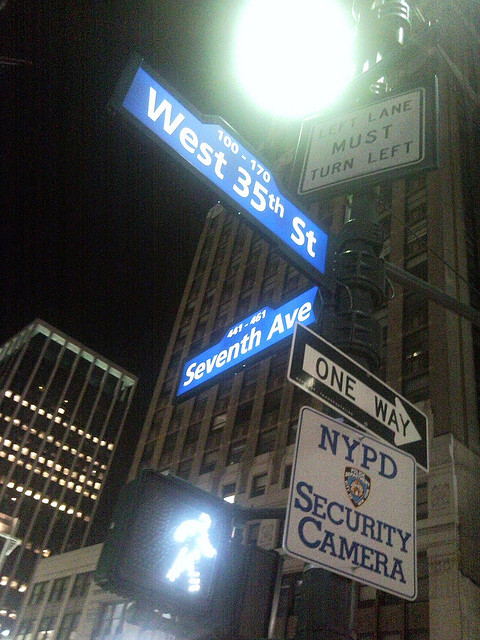Read and extract the text from this image. LEFT LANE MUST TURN LEFT CAMERA Security Camera NYPD WAY ONE Ave Seventh 461 441 West 35th St 170 100 